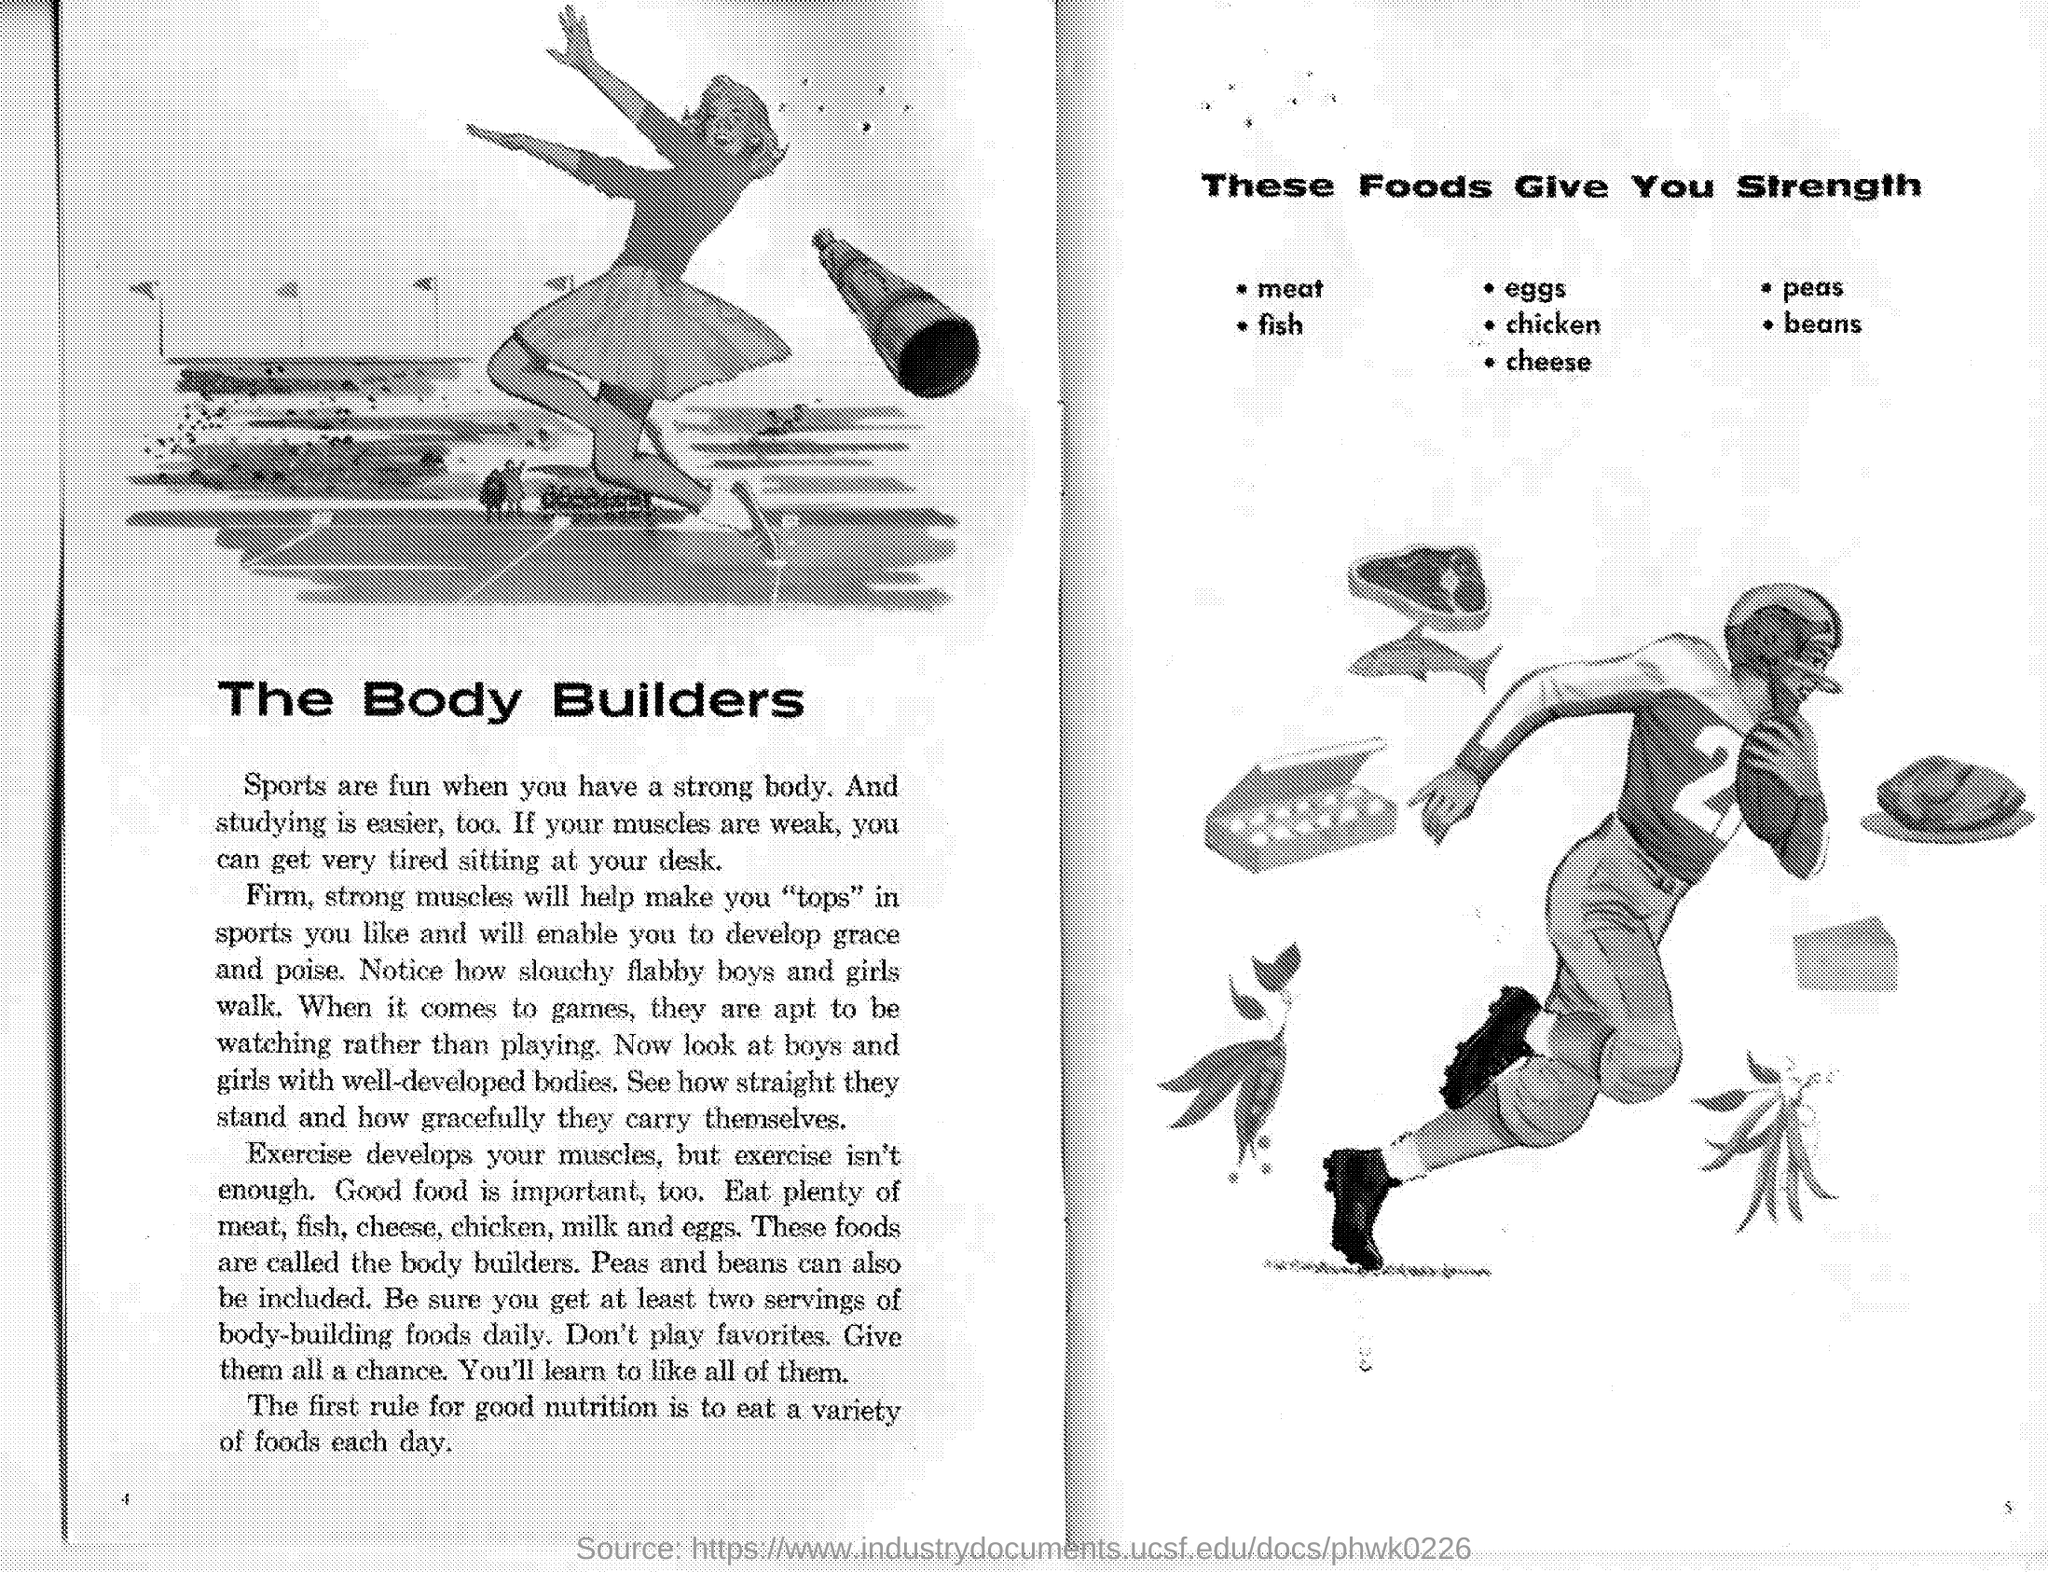Draw attention to some important aspects in this diagram. I declare that the food that gives me strength, starting with the letter "B", is beans. I declare that the food that gives me strength starting with the letter 'P' is peas. Fish is a food that provides strength. Eggs are a food that provide strength and energy. 